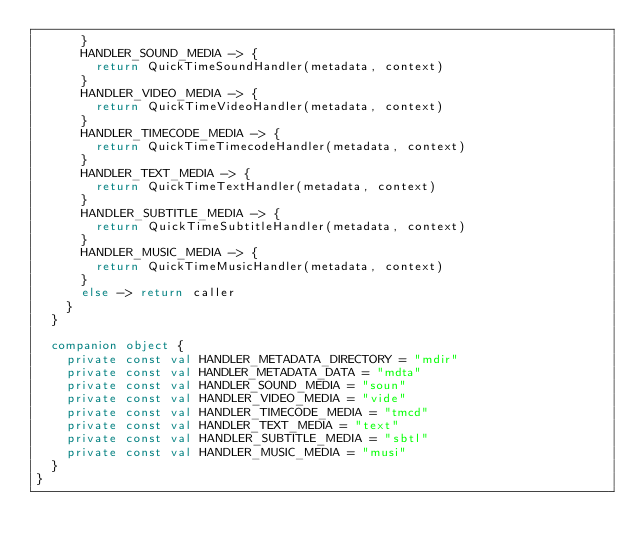<code> <loc_0><loc_0><loc_500><loc_500><_Kotlin_>      }
      HANDLER_SOUND_MEDIA -> {
        return QuickTimeSoundHandler(metadata, context)
      }
      HANDLER_VIDEO_MEDIA -> {
        return QuickTimeVideoHandler(metadata, context)
      }
      HANDLER_TIMECODE_MEDIA -> {
        return QuickTimeTimecodeHandler(metadata, context)
      }
      HANDLER_TEXT_MEDIA -> {
        return QuickTimeTextHandler(metadata, context)
      }
      HANDLER_SUBTITLE_MEDIA -> {
        return QuickTimeSubtitleHandler(metadata, context)
      }
      HANDLER_MUSIC_MEDIA -> {
        return QuickTimeMusicHandler(metadata, context)
      }
      else -> return caller
    }
  }

  companion object {
    private const val HANDLER_METADATA_DIRECTORY = "mdir"
    private const val HANDLER_METADATA_DATA = "mdta"
    private const val HANDLER_SOUND_MEDIA = "soun"
    private const val HANDLER_VIDEO_MEDIA = "vide"
    private const val HANDLER_TIMECODE_MEDIA = "tmcd"
    private const val HANDLER_TEXT_MEDIA = "text"
    private const val HANDLER_SUBTITLE_MEDIA = "sbtl"
    private const val HANDLER_MUSIC_MEDIA = "musi"
  }
}
</code> 